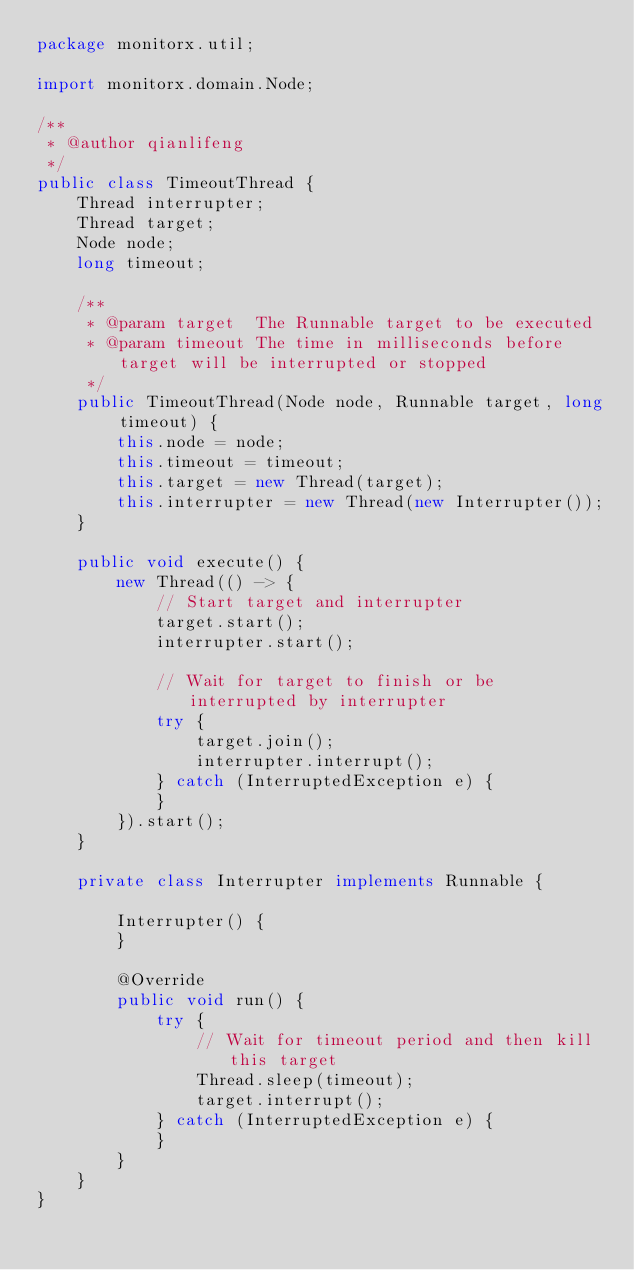<code> <loc_0><loc_0><loc_500><loc_500><_Java_>package monitorx.util;

import monitorx.domain.Node;

/**
 * @author qianlifeng
 */
public class TimeoutThread {
    Thread interrupter;
    Thread target;
    Node node;
    long timeout;

    /**
     * @param target  The Runnable target to be executed
     * @param timeout The time in milliseconds before target will be interrupted or stopped
     */
    public TimeoutThread(Node node, Runnable target, long timeout) {
        this.node = node;
        this.timeout = timeout;
        this.target = new Thread(target);
        this.interrupter = new Thread(new Interrupter());
    }

    public void execute() {
        new Thread(() -> {
            // Start target and interrupter
            target.start();
            interrupter.start();

            // Wait for target to finish or be interrupted by interrupter
            try {
                target.join();
                interrupter.interrupt();
            } catch (InterruptedException e) {
            }
        }).start();
    }

    private class Interrupter implements Runnable {

        Interrupter() {
        }

        @Override
        public void run() {
            try {
                // Wait for timeout period and then kill this target
                Thread.sleep(timeout);
                target.interrupt();
            } catch (InterruptedException e) {
            }
        }
    }
}
</code> 